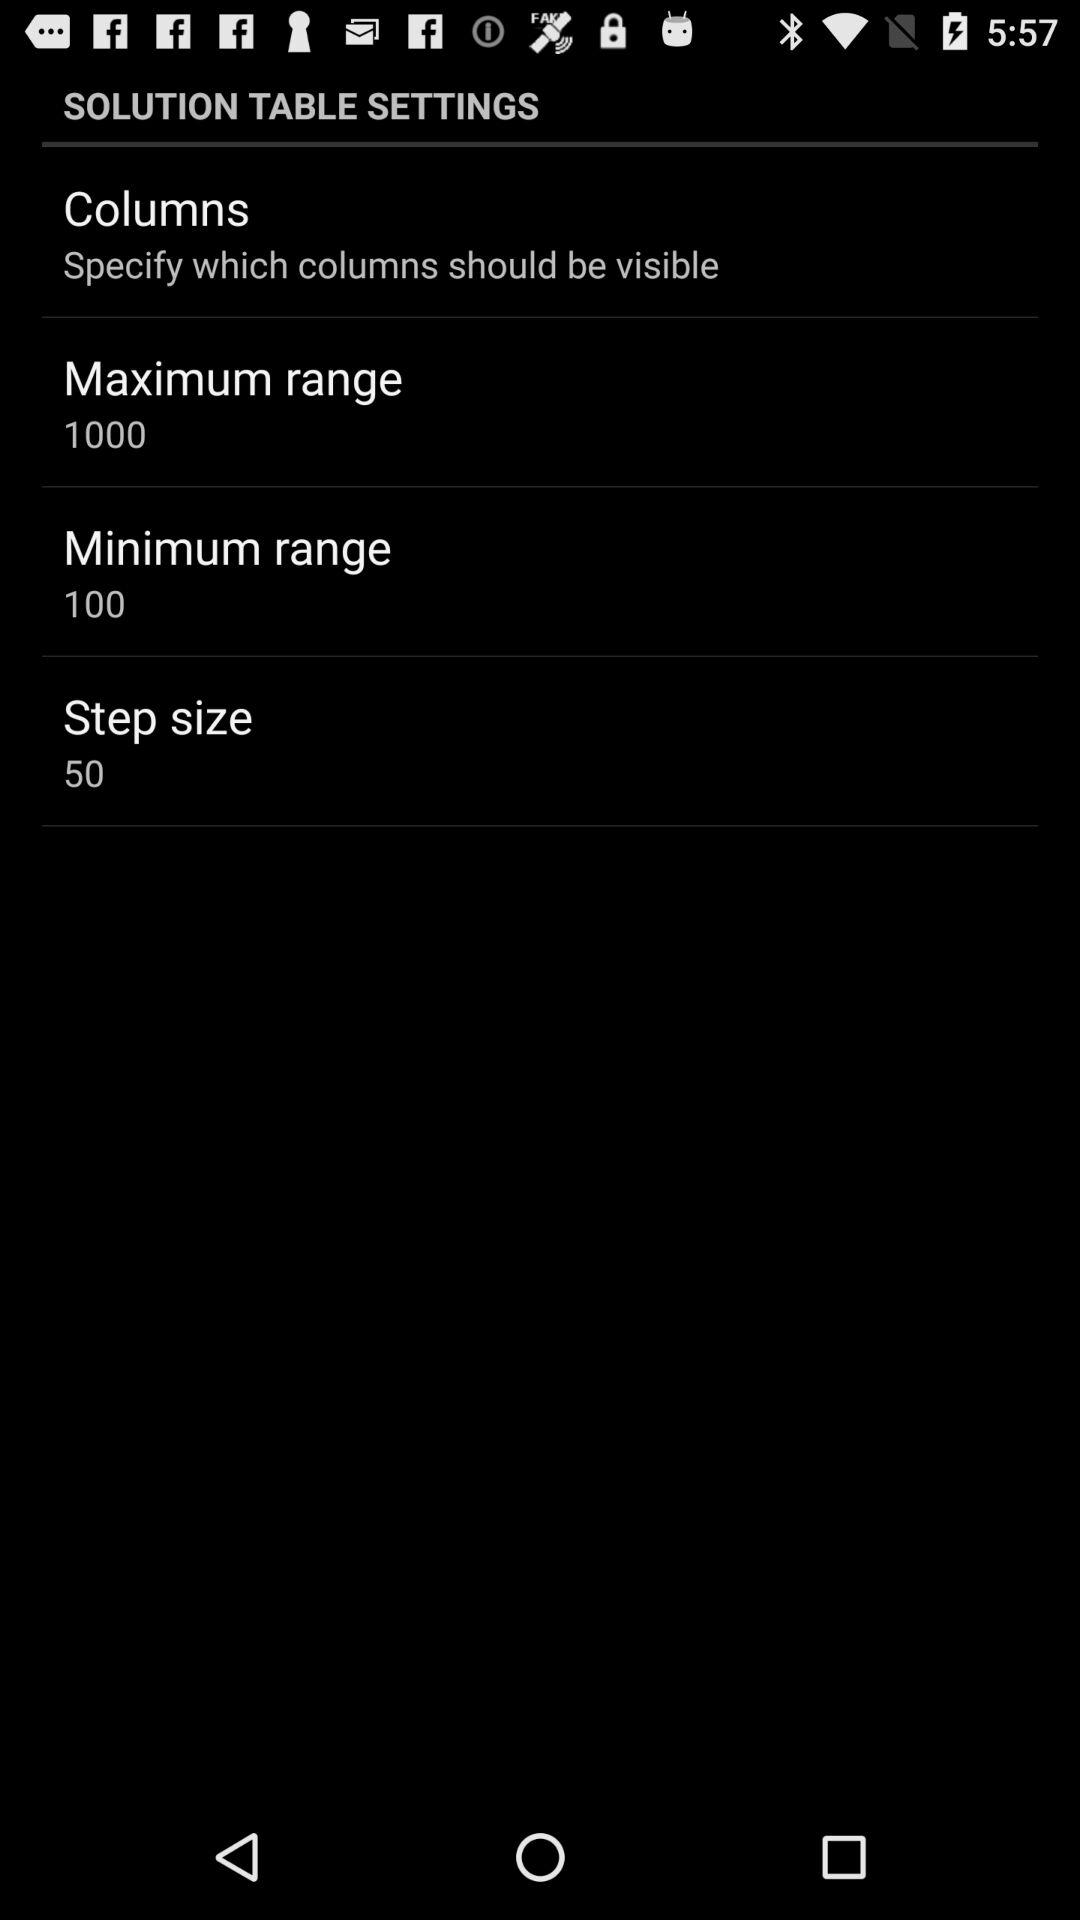What is the "Maximum range"? The "Maximum range" is 1000. 